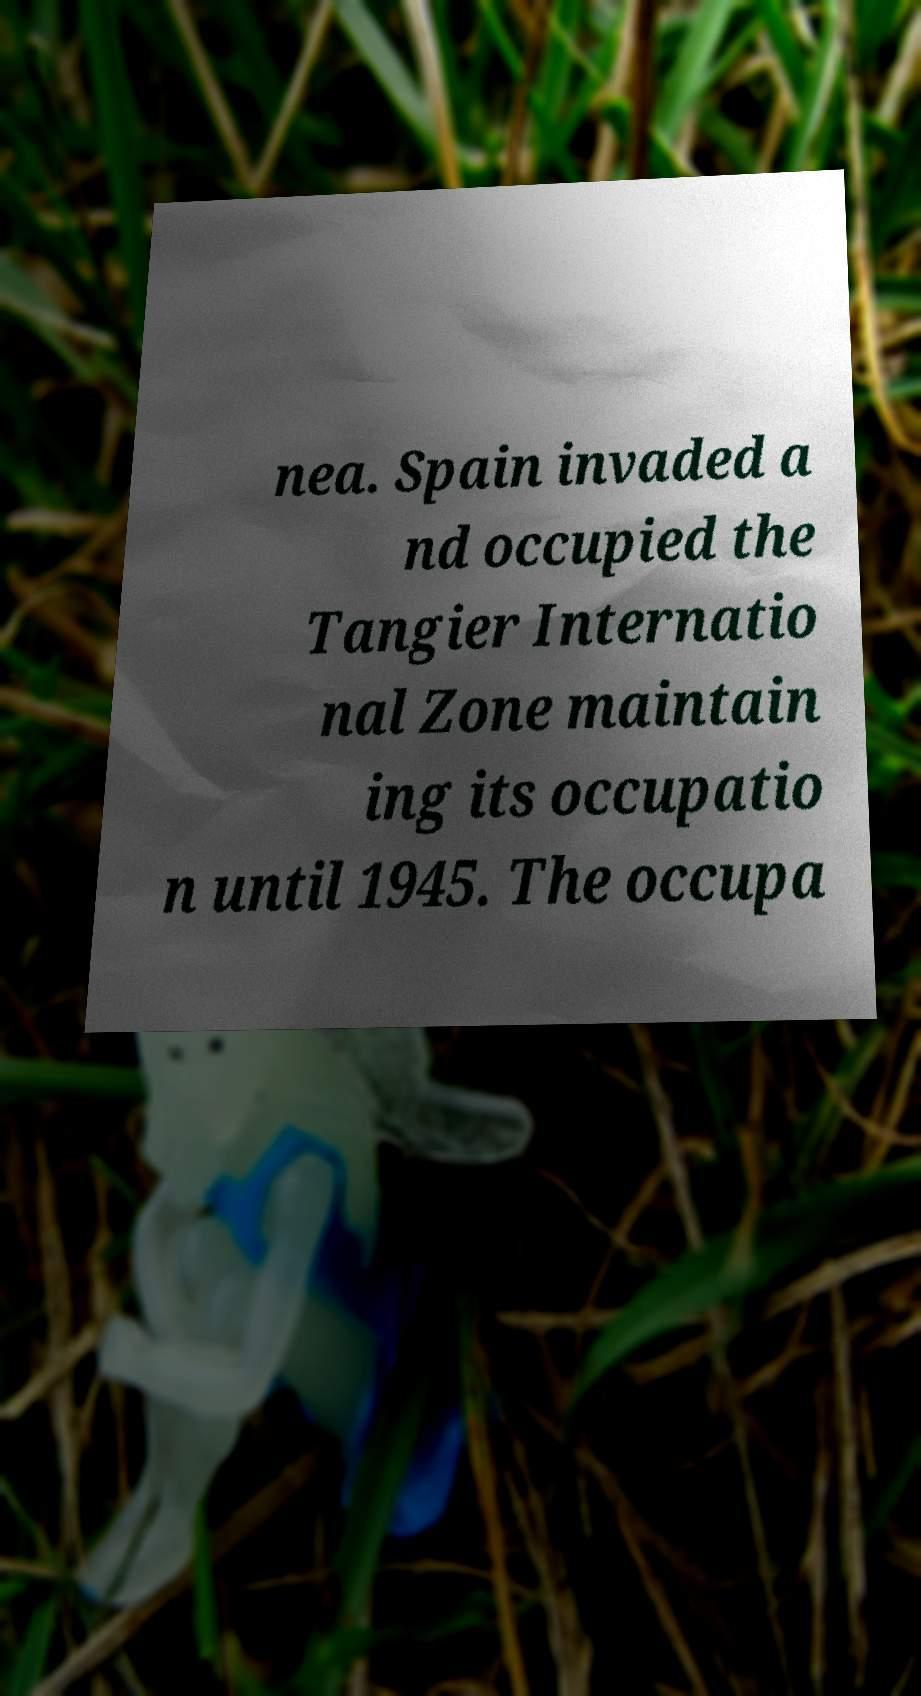Could you extract and type out the text from this image? nea. Spain invaded a nd occupied the Tangier Internatio nal Zone maintain ing its occupatio n until 1945. The occupa 